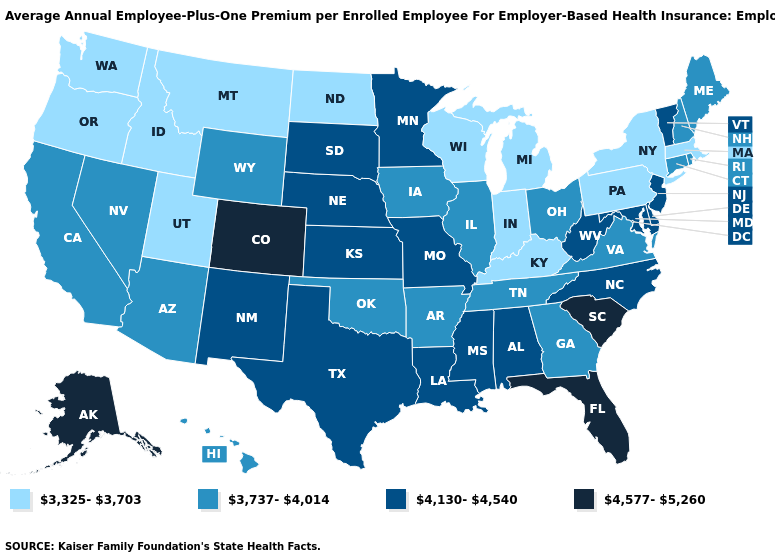Which states hav the highest value in the Northeast?
Concise answer only. New Jersey, Vermont. What is the lowest value in states that border Minnesota?
Keep it brief. 3,325-3,703. What is the value of Virginia?
Be succinct. 3,737-4,014. What is the highest value in states that border Colorado?
Write a very short answer. 4,130-4,540. Among the states that border Arizona , which have the highest value?
Give a very brief answer. Colorado. Name the states that have a value in the range 4,130-4,540?
Short answer required. Alabama, Delaware, Kansas, Louisiana, Maryland, Minnesota, Mississippi, Missouri, Nebraska, New Jersey, New Mexico, North Carolina, South Dakota, Texas, Vermont, West Virginia. What is the value of Texas?
Quick response, please. 4,130-4,540. Name the states that have a value in the range 4,130-4,540?
Give a very brief answer. Alabama, Delaware, Kansas, Louisiana, Maryland, Minnesota, Mississippi, Missouri, Nebraska, New Jersey, New Mexico, North Carolina, South Dakota, Texas, Vermont, West Virginia. What is the value of Minnesota?
Keep it brief. 4,130-4,540. What is the lowest value in the USA?
Answer briefly. 3,325-3,703. What is the value of Maine?
Give a very brief answer. 3,737-4,014. What is the value of Georgia?
Give a very brief answer. 3,737-4,014. Name the states that have a value in the range 4,130-4,540?
Keep it brief. Alabama, Delaware, Kansas, Louisiana, Maryland, Minnesota, Mississippi, Missouri, Nebraska, New Jersey, New Mexico, North Carolina, South Dakota, Texas, Vermont, West Virginia. What is the value of Colorado?
Concise answer only. 4,577-5,260. Does the first symbol in the legend represent the smallest category?
Write a very short answer. Yes. 